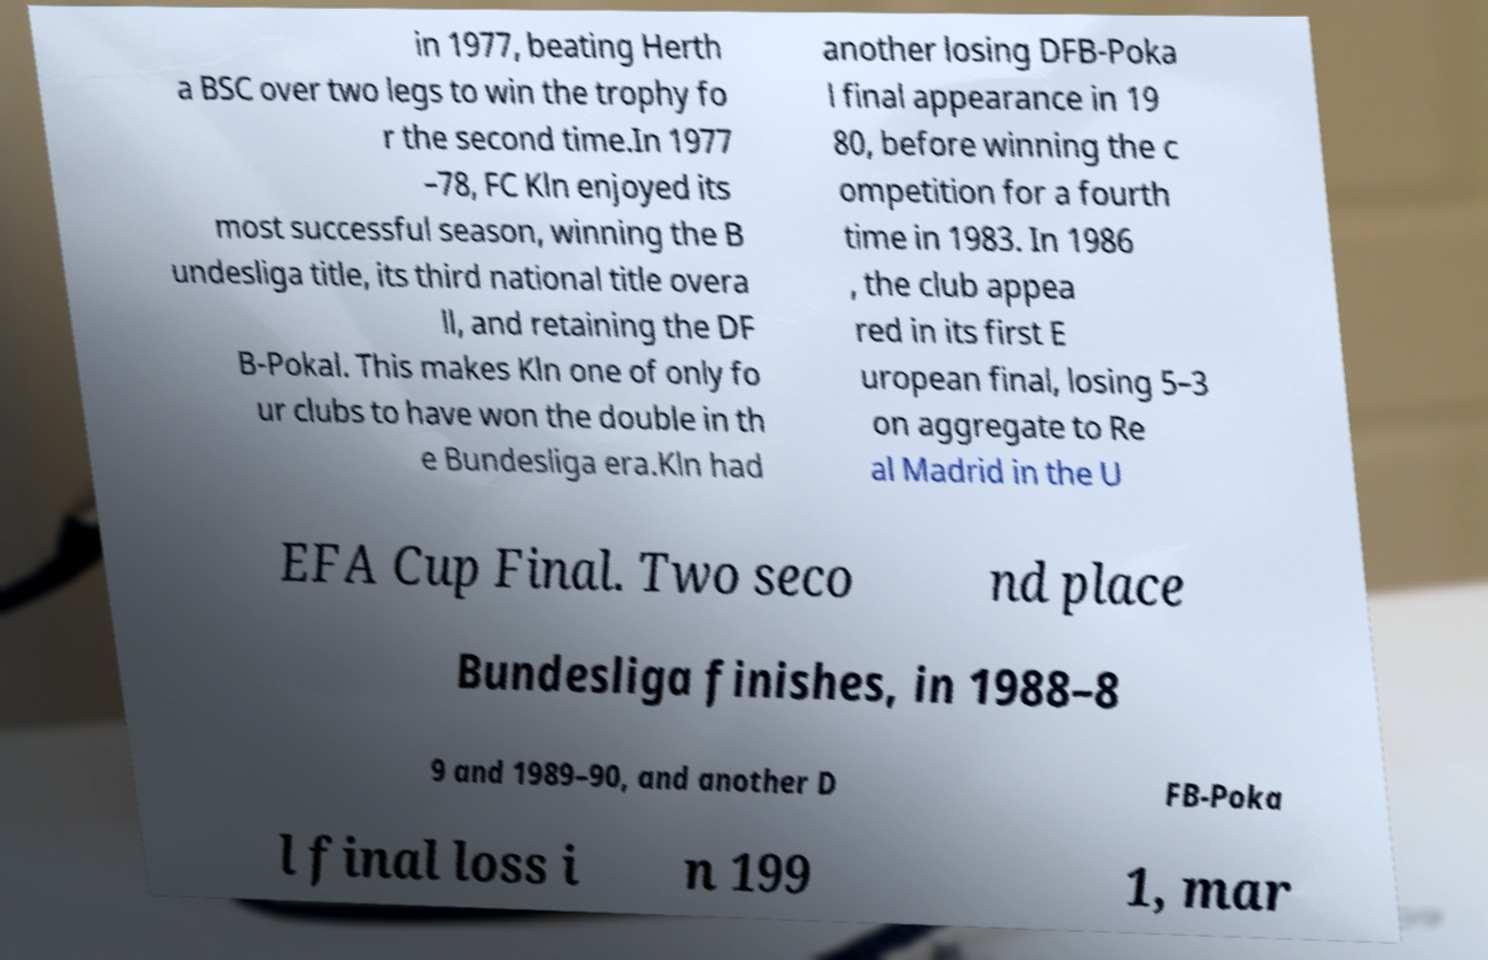Please read and relay the text visible in this image. What does it say? in 1977, beating Herth a BSC over two legs to win the trophy fo r the second time.In 1977 –78, FC Kln enjoyed its most successful season, winning the B undesliga title, its third national title overa ll, and retaining the DF B-Pokal. This makes Kln one of only fo ur clubs to have won the double in th e Bundesliga era.Kln had another losing DFB-Poka l final appearance in 19 80, before winning the c ompetition for a fourth time in 1983. In 1986 , the club appea red in its first E uropean final, losing 5–3 on aggregate to Re al Madrid in the U EFA Cup Final. Two seco nd place Bundesliga finishes, in 1988–8 9 and 1989–90, and another D FB-Poka l final loss i n 199 1, mar 